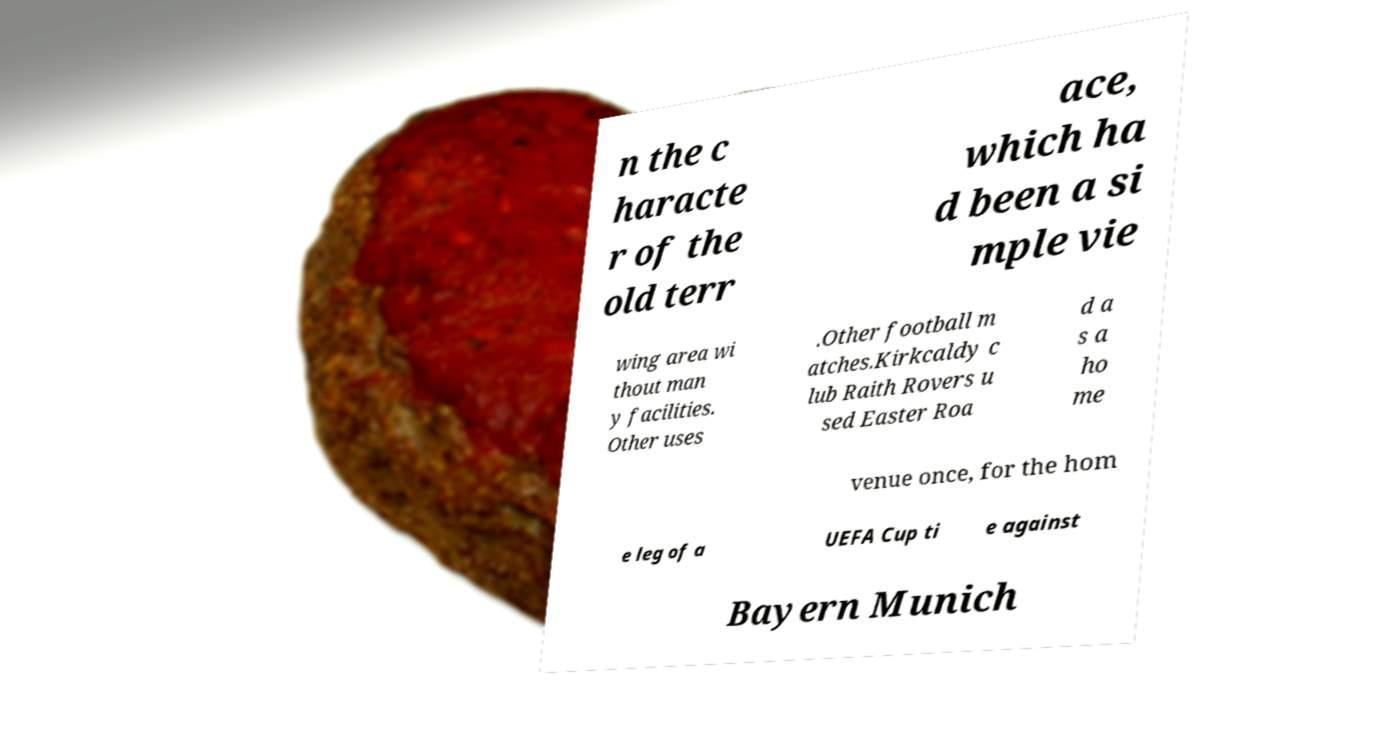For documentation purposes, I need the text within this image transcribed. Could you provide that? n the c haracte r of the old terr ace, which ha d been a si mple vie wing area wi thout man y facilities. Other uses .Other football m atches.Kirkcaldy c lub Raith Rovers u sed Easter Roa d a s a ho me venue once, for the hom e leg of a UEFA Cup ti e against Bayern Munich 